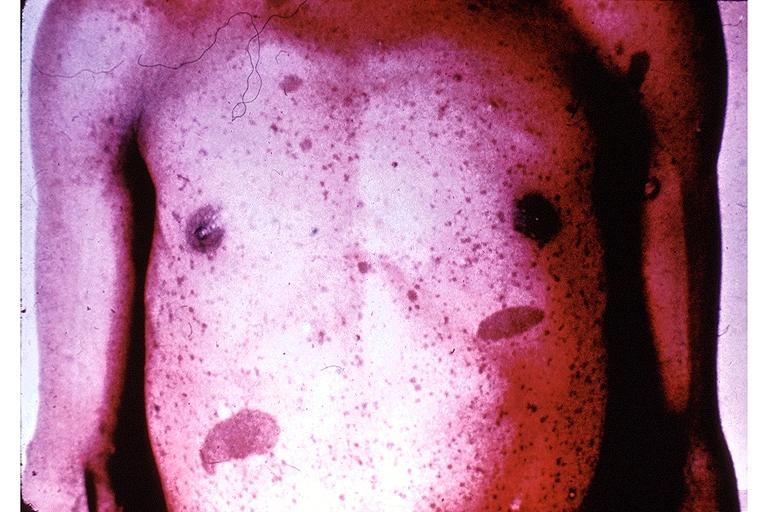does normal ovary show neurofibromatosis-cafe-au-lait pigmentation?
Answer the question using a single word or phrase. No 